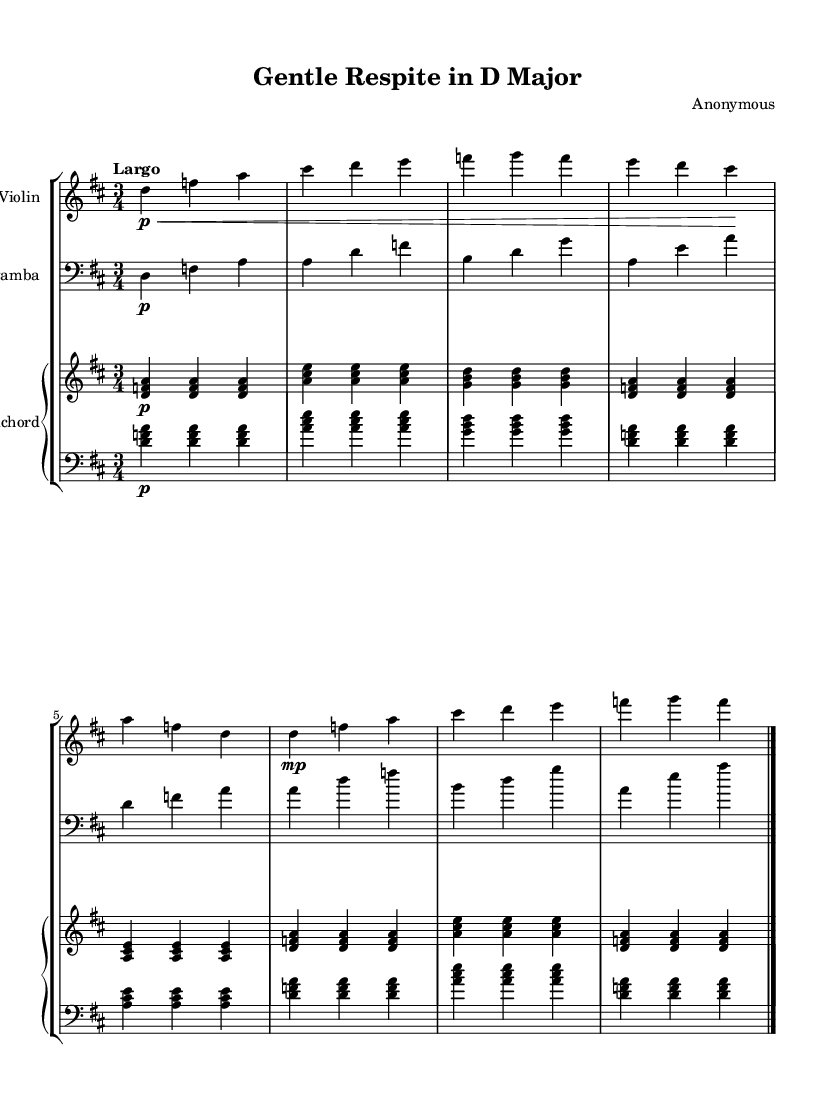What is the key signature of this music? The key signature is D major, which has two sharps (F# and C#). This can be identified by the presence of the key signature symbol at the beginning of the staff notation, indicating that the piece is in D major.
Answer: D major What is the time signature of the music? The time signature is 3/4, which is indicated by the number '3' above the number '4' at the beginning of the score. This denotes that there are three beats in every measure and that the quarter note gets one beat.
Answer: 3/4 What is the tempo marking of this piece? The tempo marking is "Largo," which is written at the beginning of the score. Largo typically indicates a slow and broad tempo, contributing to the relaxing character of the chamber music.
Answer: Largo How many instruments are featured in this chamber music? There are three instruments featured in this chamber music: Violin, Viola da gamba, and Harpsichord. This can be determined by looking at the staff groupings, where each instrument is labeled accordingly.
Answer: Three What dynamic marking is used for the Violin at the beginning? The dynamic marking is "p," indicating that the violin should play softly. This is marked as a 'p' immediately following the note in the first measure.
Answer: p What musical era does this piece belong to? This piece belongs to the Baroque era, which is determined by its stylistic features such as the use of ornamentation, the specific instrumentation, and the typical characteristics of the harmonic structure prevalent during that time.
Answer: Baroque What is the structure of this piece in terms of musical form? The structure of this piece follows a simple ABA form, where the measures played by the violin and viola da gamba present a recurring theme. This is determined by observing the repetition and variation of phrases throughout the composition.
Answer: ABA 